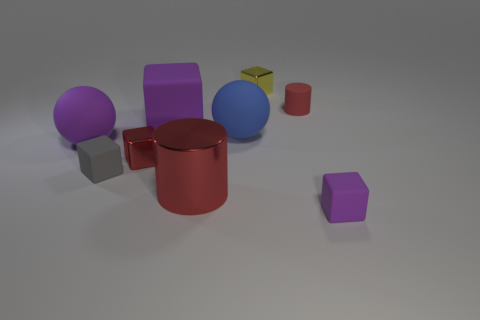Subtract all purple blocks. How many blocks are left? 3 Subtract all blue cylinders. How many purple cubes are left? 2 Subtract 1 cubes. How many cubes are left? 4 Subtract all purple balls. How many balls are left? 1 Subtract all cyan spheres. Subtract all yellow cylinders. How many spheres are left? 2 Subtract all small blue blocks. Subtract all large things. How many objects are left? 5 Add 1 rubber spheres. How many rubber spheres are left? 3 Add 5 small purple cubes. How many small purple cubes exist? 6 Subtract 0 green cubes. How many objects are left? 9 Subtract all balls. How many objects are left? 7 